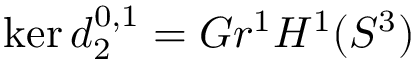Convert formula to latex. <formula><loc_0><loc_0><loc_500><loc_500>\ker d _ { 2 } ^ { 0 , 1 } = G r ^ { 1 } H ^ { 1 } ( S ^ { 3 } )</formula> 